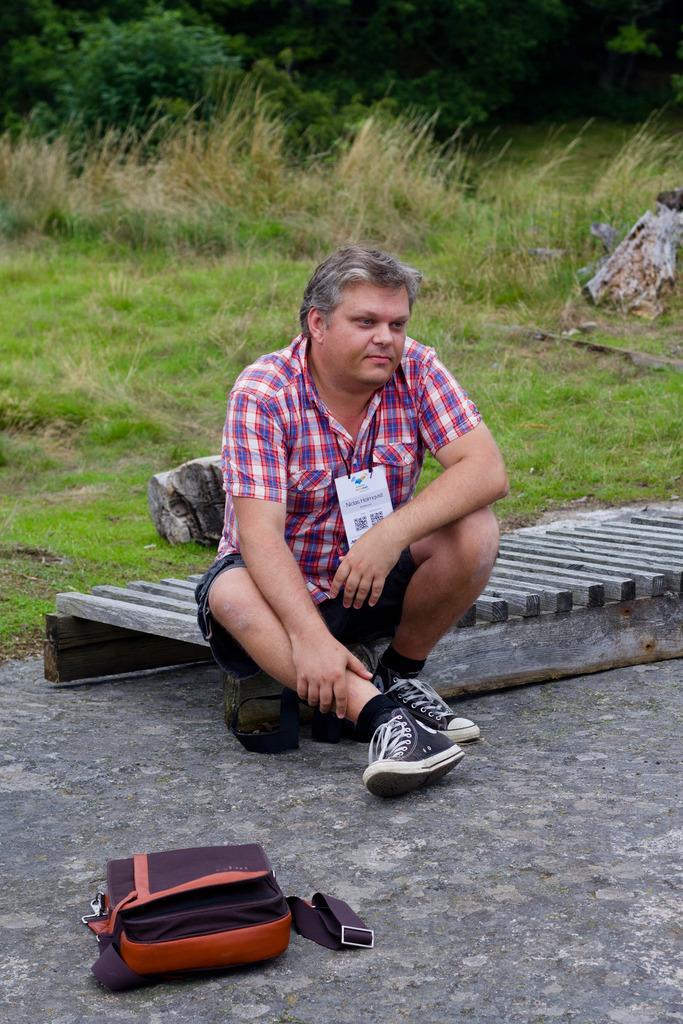In one or two sentences, can you explain what this image depicts? In this picture, we see a man who is wearing an ID card is sitting on the wooden object. Beside him, we see a wooden stick. Behind him, we see a rock and grass. At the bottom, we see the pavement and a bag in brown and orange color. In the background, we see the grass and the trees. 